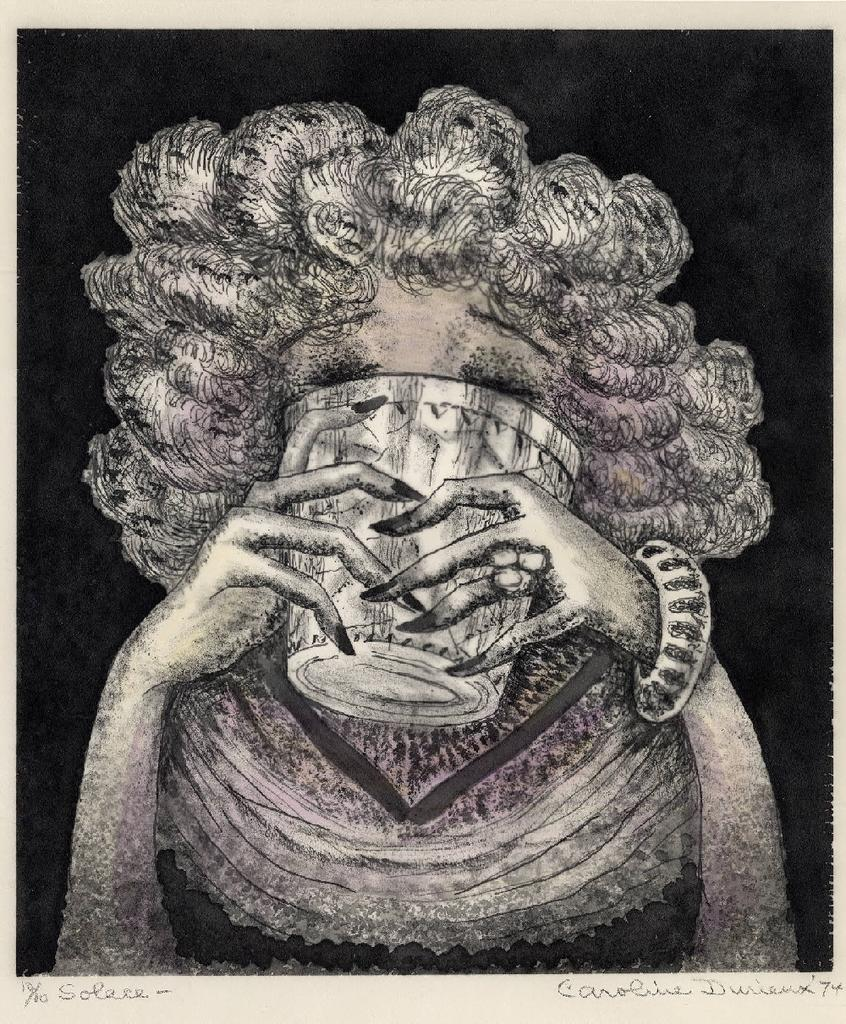What is the main subject of the image? There is a depiction of a woman in the image. What is the woman holding in the image? The woman is holding a glass. What color is the background of the image? The background of the image is black. Is there any text present in the image? Yes, there is text written on the bottom side of the image. What grade did the carpenter receive for their work in the image? There is no carpenter or mention of any work in the image; it features a woman holding a glass against a black background with text at the bottom. 